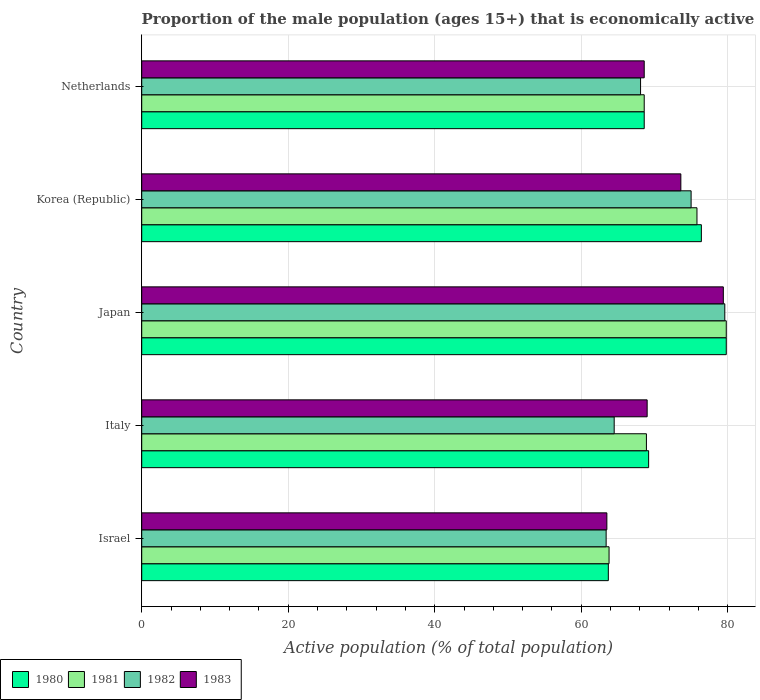Are the number of bars on each tick of the Y-axis equal?
Make the answer very short. Yes. What is the proportion of the male population that is economically active in 1983 in Netherlands?
Offer a terse response. 68.6. Across all countries, what is the maximum proportion of the male population that is economically active in 1982?
Offer a very short reply. 79.6. Across all countries, what is the minimum proportion of the male population that is economically active in 1981?
Your answer should be compact. 63.8. What is the total proportion of the male population that is economically active in 1980 in the graph?
Ensure brevity in your answer.  357.7. What is the difference between the proportion of the male population that is economically active in 1981 in Italy and that in Korea (Republic)?
Provide a succinct answer. -6.9. What is the difference between the proportion of the male population that is economically active in 1981 in Japan and the proportion of the male population that is economically active in 1980 in Italy?
Offer a very short reply. 10.6. What is the average proportion of the male population that is economically active in 1983 per country?
Offer a very short reply. 70.82. What is the difference between the proportion of the male population that is economically active in 1982 and proportion of the male population that is economically active in 1981 in Korea (Republic)?
Your answer should be very brief. -0.8. In how many countries, is the proportion of the male population that is economically active in 1983 greater than 4 %?
Provide a succinct answer. 5. What is the ratio of the proportion of the male population that is economically active in 1980 in Italy to that in Japan?
Offer a very short reply. 0.87. Is the difference between the proportion of the male population that is economically active in 1982 in Israel and Netherlands greater than the difference between the proportion of the male population that is economically active in 1981 in Israel and Netherlands?
Give a very brief answer. Yes. What is the difference between the highest and the second highest proportion of the male population that is economically active in 1983?
Your response must be concise. 5.8. What is the difference between the highest and the lowest proportion of the male population that is economically active in 1981?
Ensure brevity in your answer.  16. In how many countries, is the proportion of the male population that is economically active in 1980 greater than the average proportion of the male population that is economically active in 1980 taken over all countries?
Provide a succinct answer. 2. Is it the case that in every country, the sum of the proportion of the male population that is economically active in 1980 and proportion of the male population that is economically active in 1981 is greater than the sum of proportion of the male population that is economically active in 1983 and proportion of the male population that is economically active in 1982?
Provide a short and direct response. No. What does the 4th bar from the top in Israel represents?
Your answer should be compact. 1980. What does the 1st bar from the bottom in Korea (Republic) represents?
Offer a very short reply. 1980. Is it the case that in every country, the sum of the proportion of the male population that is economically active in 1982 and proportion of the male population that is economically active in 1981 is greater than the proportion of the male population that is economically active in 1980?
Your answer should be very brief. Yes. Are all the bars in the graph horizontal?
Keep it short and to the point. Yes. What is the difference between two consecutive major ticks on the X-axis?
Offer a very short reply. 20. Are the values on the major ticks of X-axis written in scientific E-notation?
Give a very brief answer. No. Does the graph contain grids?
Ensure brevity in your answer.  Yes. How many legend labels are there?
Keep it short and to the point. 4. How are the legend labels stacked?
Ensure brevity in your answer.  Horizontal. What is the title of the graph?
Offer a very short reply. Proportion of the male population (ages 15+) that is economically active. Does "2013" appear as one of the legend labels in the graph?
Give a very brief answer. No. What is the label or title of the X-axis?
Keep it short and to the point. Active population (% of total population). What is the Active population (% of total population) in 1980 in Israel?
Give a very brief answer. 63.7. What is the Active population (% of total population) of 1981 in Israel?
Give a very brief answer. 63.8. What is the Active population (% of total population) of 1982 in Israel?
Make the answer very short. 63.4. What is the Active population (% of total population) of 1983 in Israel?
Keep it short and to the point. 63.5. What is the Active population (% of total population) in 1980 in Italy?
Ensure brevity in your answer.  69.2. What is the Active population (% of total population) in 1981 in Italy?
Offer a very short reply. 68.9. What is the Active population (% of total population) of 1982 in Italy?
Your answer should be compact. 64.5. What is the Active population (% of total population) of 1980 in Japan?
Provide a succinct answer. 79.8. What is the Active population (% of total population) in 1981 in Japan?
Your answer should be very brief. 79.8. What is the Active population (% of total population) in 1982 in Japan?
Your answer should be compact. 79.6. What is the Active population (% of total population) in 1983 in Japan?
Offer a very short reply. 79.4. What is the Active population (% of total population) in 1980 in Korea (Republic)?
Ensure brevity in your answer.  76.4. What is the Active population (% of total population) in 1981 in Korea (Republic)?
Ensure brevity in your answer.  75.8. What is the Active population (% of total population) in 1983 in Korea (Republic)?
Your answer should be compact. 73.6. What is the Active population (% of total population) of 1980 in Netherlands?
Offer a very short reply. 68.6. What is the Active population (% of total population) of 1981 in Netherlands?
Your response must be concise. 68.6. What is the Active population (% of total population) in 1982 in Netherlands?
Make the answer very short. 68.1. What is the Active population (% of total population) in 1983 in Netherlands?
Your answer should be compact. 68.6. Across all countries, what is the maximum Active population (% of total population) in 1980?
Offer a very short reply. 79.8. Across all countries, what is the maximum Active population (% of total population) of 1981?
Provide a short and direct response. 79.8. Across all countries, what is the maximum Active population (% of total population) in 1982?
Keep it short and to the point. 79.6. Across all countries, what is the maximum Active population (% of total population) in 1983?
Provide a short and direct response. 79.4. Across all countries, what is the minimum Active population (% of total population) in 1980?
Keep it short and to the point. 63.7. Across all countries, what is the minimum Active population (% of total population) of 1981?
Provide a short and direct response. 63.8. Across all countries, what is the minimum Active population (% of total population) in 1982?
Provide a short and direct response. 63.4. Across all countries, what is the minimum Active population (% of total population) of 1983?
Offer a very short reply. 63.5. What is the total Active population (% of total population) in 1980 in the graph?
Keep it short and to the point. 357.7. What is the total Active population (% of total population) of 1981 in the graph?
Your answer should be very brief. 356.9. What is the total Active population (% of total population) in 1982 in the graph?
Give a very brief answer. 350.6. What is the total Active population (% of total population) in 1983 in the graph?
Provide a succinct answer. 354.1. What is the difference between the Active population (% of total population) of 1981 in Israel and that in Italy?
Give a very brief answer. -5.1. What is the difference between the Active population (% of total population) of 1983 in Israel and that in Italy?
Your answer should be very brief. -5.5. What is the difference between the Active population (% of total population) of 1980 in Israel and that in Japan?
Make the answer very short. -16.1. What is the difference between the Active population (% of total population) of 1981 in Israel and that in Japan?
Provide a short and direct response. -16. What is the difference between the Active population (% of total population) in 1982 in Israel and that in Japan?
Provide a succinct answer. -16.2. What is the difference between the Active population (% of total population) of 1983 in Israel and that in Japan?
Offer a terse response. -15.9. What is the difference between the Active population (% of total population) of 1980 in Israel and that in Korea (Republic)?
Make the answer very short. -12.7. What is the difference between the Active population (% of total population) in 1981 in Israel and that in Korea (Republic)?
Offer a terse response. -12. What is the difference between the Active population (% of total population) of 1982 in Israel and that in Korea (Republic)?
Provide a succinct answer. -11.6. What is the difference between the Active population (% of total population) in 1980 in Italy and that in Japan?
Make the answer very short. -10.6. What is the difference between the Active population (% of total population) of 1982 in Italy and that in Japan?
Offer a terse response. -15.1. What is the difference between the Active population (% of total population) of 1982 in Italy and that in Korea (Republic)?
Make the answer very short. -10.5. What is the difference between the Active population (% of total population) of 1980 in Italy and that in Netherlands?
Keep it short and to the point. 0.6. What is the difference between the Active population (% of total population) in 1981 in Italy and that in Netherlands?
Provide a short and direct response. 0.3. What is the difference between the Active population (% of total population) of 1982 in Italy and that in Netherlands?
Ensure brevity in your answer.  -3.6. What is the difference between the Active population (% of total population) in 1983 in Italy and that in Netherlands?
Ensure brevity in your answer.  0.4. What is the difference between the Active population (% of total population) in 1981 in Japan and that in Korea (Republic)?
Make the answer very short. 4. What is the difference between the Active population (% of total population) in 1982 in Japan and that in Korea (Republic)?
Keep it short and to the point. 4.6. What is the difference between the Active population (% of total population) in 1983 in Japan and that in Korea (Republic)?
Provide a short and direct response. 5.8. What is the difference between the Active population (% of total population) of 1981 in Japan and that in Netherlands?
Ensure brevity in your answer.  11.2. What is the difference between the Active population (% of total population) of 1981 in Korea (Republic) and that in Netherlands?
Ensure brevity in your answer.  7.2. What is the difference between the Active population (% of total population) in 1983 in Korea (Republic) and that in Netherlands?
Make the answer very short. 5. What is the difference between the Active population (% of total population) of 1980 in Israel and the Active population (% of total population) of 1981 in Italy?
Your response must be concise. -5.2. What is the difference between the Active population (% of total population) of 1980 in Israel and the Active population (% of total population) of 1982 in Italy?
Provide a succinct answer. -0.8. What is the difference between the Active population (% of total population) in 1981 in Israel and the Active population (% of total population) in 1982 in Italy?
Offer a very short reply. -0.7. What is the difference between the Active population (% of total population) of 1980 in Israel and the Active population (% of total population) of 1981 in Japan?
Ensure brevity in your answer.  -16.1. What is the difference between the Active population (% of total population) of 1980 in Israel and the Active population (% of total population) of 1982 in Japan?
Offer a very short reply. -15.9. What is the difference between the Active population (% of total population) in 1980 in Israel and the Active population (% of total population) in 1983 in Japan?
Your answer should be very brief. -15.7. What is the difference between the Active population (% of total population) in 1981 in Israel and the Active population (% of total population) in 1982 in Japan?
Offer a very short reply. -15.8. What is the difference between the Active population (% of total population) of 1981 in Israel and the Active population (% of total population) of 1983 in Japan?
Offer a very short reply. -15.6. What is the difference between the Active population (% of total population) of 1982 in Israel and the Active population (% of total population) of 1983 in Japan?
Offer a very short reply. -16. What is the difference between the Active population (% of total population) of 1980 in Israel and the Active population (% of total population) of 1981 in Korea (Republic)?
Give a very brief answer. -12.1. What is the difference between the Active population (% of total population) of 1980 in Israel and the Active population (% of total population) of 1983 in Korea (Republic)?
Ensure brevity in your answer.  -9.9. What is the difference between the Active population (% of total population) in 1981 in Israel and the Active population (% of total population) in 1982 in Korea (Republic)?
Keep it short and to the point. -11.2. What is the difference between the Active population (% of total population) of 1980 in Israel and the Active population (% of total population) of 1981 in Netherlands?
Offer a terse response. -4.9. What is the difference between the Active population (% of total population) in 1980 in Israel and the Active population (% of total population) in 1982 in Netherlands?
Ensure brevity in your answer.  -4.4. What is the difference between the Active population (% of total population) in 1981 in Israel and the Active population (% of total population) in 1983 in Netherlands?
Provide a short and direct response. -4.8. What is the difference between the Active population (% of total population) in 1982 in Israel and the Active population (% of total population) in 1983 in Netherlands?
Offer a very short reply. -5.2. What is the difference between the Active population (% of total population) in 1980 in Italy and the Active population (% of total population) in 1983 in Japan?
Give a very brief answer. -10.2. What is the difference between the Active population (% of total population) in 1981 in Italy and the Active population (% of total population) in 1982 in Japan?
Your answer should be compact. -10.7. What is the difference between the Active population (% of total population) of 1982 in Italy and the Active population (% of total population) of 1983 in Japan?
Offer a very short reply. -14.9. What is the difference between the Active population (% of total population) in 1980 in Italy and the Active population (% of total population) in 1981 in Korea (Republic)?
Make the answer very short. -6.6. What is the difference between the Active population (% of total population) of 1980 in Italy and the Active population (% of total population) of 1982 in Korea (Republic)?
Make the answer very short. -5.8. What is the difference between the Active population (% of total population) of 1980 in Italy and the Active population (% of total population) of 1983 in Korea (Republic)?
Your response must be concise. -4.4. What is the difference between the Active population (% of total population) in 1981 in Italy and the Active population (% of total population) in 1983 in Korea (Republic)?
Offer a very short reply. -4.7. What is the difference between the Active population (% of total population) in 1980 in Italy and the Active population (% of total population) in 1981 in Netherlands?
Keep it short and to the point. 0.6. What is the difference between the Active population (% of total population) of 1980 in Italy and the Active population (% of total population) of 1982 in Netherlands?
Offer a terse response. 1.1. What is the difference between the Active population (% of total population) in 1981 in Italy and the Active population (% of total population) in 1982 in Netherlands?
Offer a very short reply. 0.8. What is the difference between the Active population (% of total population) in 1981 in Italy and the Active population (% of total population) in 1983 in Netherlands?
Make the answer very short. 0.3. What is the difference between the Active population (% of total population) in 1980 in Japan and the Active population (% of total population) in 1981 in Korea (Republic)?
Your answer should be very brief. 4. What is the difference between the Active population (% of total population) of 1980 in Japan and the Active population (% of total population) of 1982 in Korea (Republic)?
Provide a succinct answer. 4.8. What is the difference between the Active population (% of total population) of 1980 in Japan and the Active population (% of total population) of 1983 in Korea (Republic)?
Give a very brief answer. 6.2. What is the difference between the Active population (% of total population) in 1982 in Japan and the Active population (% of total population) in 1983 in Korea (Republic)?
Offer a very short reply. 6. What is the difference between the Active population (% of total population) in 1982 in Japan and the Active population (% of total population) in 1983 in Netherlands?
Your response must be concise. 11. What is the difference between the Active population (% of total population) of 1980 in Korea (Republic) and the Active population (% of total population) of 1981 in Netherlands?
Offer a terse response. 7.8. What is the difference between the Active population (% of total population) in 1980 in Korea (Republic) and the Active population (% of total population) in 1982 in Netherlands?
Offer a terse response. 8.3. What is the difference between the Active population (% of total population) in 1980 in Korea (Republic) and the Active population (% of total population) in 1983 in Netherlands?
Your answer should be very brief. 7.8. What is the average Active population (% of total population) of 1980 per country?
Offer a very short reply. 71.54. What is the average Active population (% of total population) of 1981 per country?
Provide a succinct answer. 71.38. What is the average Active population (% of total population) of 1982 per country?
Your response must be concise. 70.12. What is the average Active population (% of total population) in 1983 per country?
Your answer should be compact. 70.82. What is the difference between the Active population (% of total population) of 1980 and Active population (% of total population) of 1983 in Israel?
Make the answer very short. 0.2. What is the difference between the Active population (% of total population) in 1981 and Active population (% of total population) in 1983 in Israel?
Your answer should be very brief. 0.3. What is the difference between the Active population (% of total population) in 1980 and Active population (% of total population) in 1982 in Italy?
Keep it short and to the point. 4.7. What is the difference between the Active population (% of total population) in 1980 and Active population (% of total population) in 1983 in Italy?
Provide a succinct answer. 0.2. What is the difference between the Active population (% of total population) of 1980 and Active population (% of total population) of 1982 in Japan?
Ensure brevity in your answer.  0.2. What is the difference between the Active population (% of total population) of 1981 and Active population (% of total population) of 1982 in Japan?
Provide a short and direct response. 0.2. What is the difference between the Active population (% of total population) in 1980 and Active population (% of total population) in 1981 in Korea (Republic)?
Keep it short and to the point. 0.6. What is the difference between the Active population (% of total population) of 1980 and Active population (% of total population) of 1983 in Korea (Republic)?
Offer a very short reply. 2.8. What is the difference between the Active population (% of total population) in 1981 and Active population (% of total population) in 1982 in Korea (Republic)?
Make the answer very short. 0.8. What is the difference between the Active population (% of total population) of 1980 and Active population (% of total population) of 1982 in Netherlands?
Ensure brevity in your answer.  0.5. What is the difference between the Active population (% of total population) in 1980 and Active population (% of total population) in 1983 in Netherlands?
Keep it short and to the point. 0. What is the difference between the Active population (% of total population) in 1981 and Active population (% of total population) in 1982 in Netherlands?
Offer a very short reply. 0.5. What is the difference between the Active population (% of total population) of 1982 and Active population (% of total population) of 1983 in Netherlands?
Keep it short and to the point. -0.5. What is the ratio of the Active population (% of total population) in 1980 in Israel to that in Italy?
Offer a very short reply. 0.92. What is the ratio of the Active population (% of total population) of 1981 in Israel to that in Italy?
Offer a terse response. 0.93. What is the ratio of the Active population (% of total population) in 1982 in Israel to that in Italy?
Your answer should be very brief. 0.98. What is the ratio of the Active population (% of total population) in 1983 in Israel to that in Italy?
Offer a very short reply. 0.92. What is the ratio of the Active population (% of total population) of 1980 in Israel to that in Japan?
Give a very brief answer. 0.8. What is the ratio of the Active population (% of total population) of 1981 in Israel to that in Japan?
Offer a very short reply. 0.8. What is the ratio of the Active population (% of total population) in 1982 in Israel to that in Japan?
Offer a very short reply. 0.8. What is the ratio of the Active population (% of total population) of 1983 in Israel to that in Japan?
Provide a short and direct response. 0.8. What is the ratio of the Active population (% of total population) of 1980 in Israel to that in Korea (Republic)?
Provide a short and direct response. 0.83. What is the ratio of the Active population (% of total population) in 1981 in Israel to that in Korea (Republic)?
Ensure brevity in your answer.  0.84. What is the ratio of the Active population (% of total population) in 1982 in Israel to that in Korea (Republic)?
Keep it short and to the point. 0.85. What is the ratio of the Active population (% of total population) in 1983 in Israel to that in Korea (Republic)?
Your answer should be compact. 0.86. What is the ratio of the Active population (% of total population) in 1980 in Israel to that in Netherlands?
Provide a short and direct response. 0.93. What is the ratio of the Active population (% of total population) in 1981 in Israel to that in Netherlands?
Make the answer very short. 0.93. What is the ratio of the Active population (% of total population) of 1983 in Israel to that in Netherlands?
Your answer should be compact. 0.93. What is the ratio of the Active population (% of total population) of 1980 in Italy to that in Japan?
Ensure brevity in your answer.  0.87. What is the ratio of the Active population (% of total population) in 1981 in Italy to that in Japan?
Your response must be concise. 0.86. What is the ratio of the Active population (% of total population) in 1982 in Italy to that in Japan?
Offer a very short reply. 0.81. What is the ratio of the Active population (% of total population) in 1983 in Italy to that in Japan?
Offer a terse response. 0.87. What is the ratio of the Active population (% of total population) in 1980 in Italy to that in Korea (Republic)?
Make the answer very short. 0.91. What is the ratio of the Active population (% of total population) in 1981 in Italy to that in Korea (Republic)?
Your answer should be compact. 0.91. What is the ratio of the Active population (% of total population) of 1982 in Italy to that in Korea (Republic)?
Ensure brevity in your answer.  0.86. What is the ratio of the Active population (% of total population) of 1980 in Italy to that in Netherlands?
Offer a very short reply. 1.01. What is the ratio of the Active population (% of total population) in 1981 in Italy to that in Netherlands?
Your answer should be compact. 1. What is the ratio of the Active population (% of total population) of 1982 in Italy to that in Netherlands?
Ensure brevity in your answer.  0.95. What is the ratio of the Active population (% of total population) of 1983 in Italy to that in Netherlands?
Your answer should be very brief. 1.01. What is the ratio of the Active population (% of total population) in 1980 in Japan to that in Korea (Republic)?
Your response must be concise. 1.04. What is the ratio of the Active population (% of total population) of 1981 in Japan to that in Korea (Republic)?
Provide a succinct answer. 1.05. What is the ratio of the Active population (% of total population) in 1982 in Japan to that in Korea (Republic)?
Ensure brevity in your answer.  1.06. What is the ratio of the Active population (% of total population) in 1983 in Japan to that in Korea (Republic)?
Provide a succinct answer. 1.08. What is the ratio of the Active population (% of total population) of 1980 in Japan to that in Netherlands?
Ensure brevity in your answer.  1.16. What is the ratio of the Active population (% of total population) in 1981 in Japan to that in Netherlands?
Your answer should be very brief. 1.16. What is the ratio of the Active population (% of total population) of 1982 in Japan to that in Netherlands?
Ensure brevity in your answer.  1.17. What is the ratio of the Active population (% of total population) in 1983 in Japan to that in Netherlands?
Your response must be concise. 1.16. What is the ratio of the Active population (% of total population) of 1980 in Korea (Republic) to that in Netherlands?
Provide a succinct answer. 1.11. What is the ratio of the Active population (% of total population) in 1981 in Korea (Republic) to that in Netherlands?
Give a very brief answer. 1.1. What is the ratio of the Active population (% of total population) in 1982 in Korea (Republic) to that in Netherlands?
Ensure brevity in your answer.  1.1. What is the ratio of the Active population (% of total population) in 1983 in Korea (Republic) to that in Netherlands?
Your response must be concise. 1.07. What is the difference between the highest and the second highest Active population (% of total population) in 1982?
Give a very brief answer. 4.6. What is the difference between the highest and the lowest Active population (% of total population) in 1980?
Offer a terse response. 16.1. What is the difference between the highest and the lowest Active population (% of total population) in 1982?
Provide a short and direct response. 16.2. 